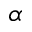Convert formula to latex. <formula><loc_0><loc_0><loc_500><loc_500>\alpha</formula> 